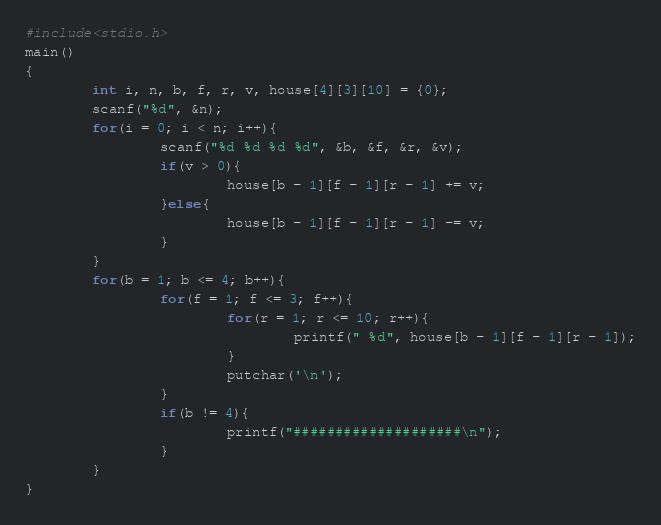<code> <loc_0><loc_0><loc_500><loc_500><_C_>#include<stdio.h>
main()
{
        int i, n, b, f, r, v, house[4][3][10] = {0};
        scanf("%d", &n);
        for(i = 0; i < n; i++){
                scanf("%d %d %d %d", &b, &f, &r, &v);
                if(v > 0){
                        house[b - 1][f - 1][r - 1] += v;
                }else{
                        house[b - 1][f - 1][r - 1] -= v;
                }
        }
        for(b = 1; b <= 4; b++){
                for(f = 1; f <= 3; f++){
                        for(r = 1; r <= 10; r++){
                                printf(" %d", house[b - 1][f - 1][r - 1]);
                        }
                        putchar('\n');
                }
                if(b != 4){
                        printf("####################\n");
                }
        }
}</code> 